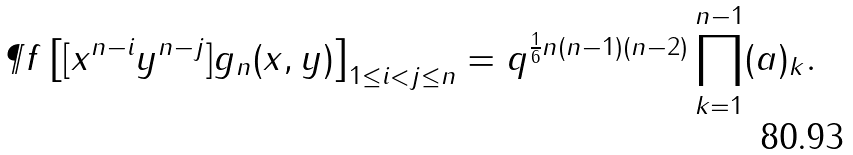<formula> <loc_0><loc_0><loc_500><loc_500>\P f \left [ [ x ^ { n - i } y ^ { n - j } ] g _ { n } ( x , y ) \right ] _ { 1 \leq i < j \leq n } = q ^ { \frac { 1 } { 6 } n ( n - 1 ) ( n - 2 ) } \prod _ { k = 1 } ^ { n - 1 } ( a ) _ { k } .</formula> 